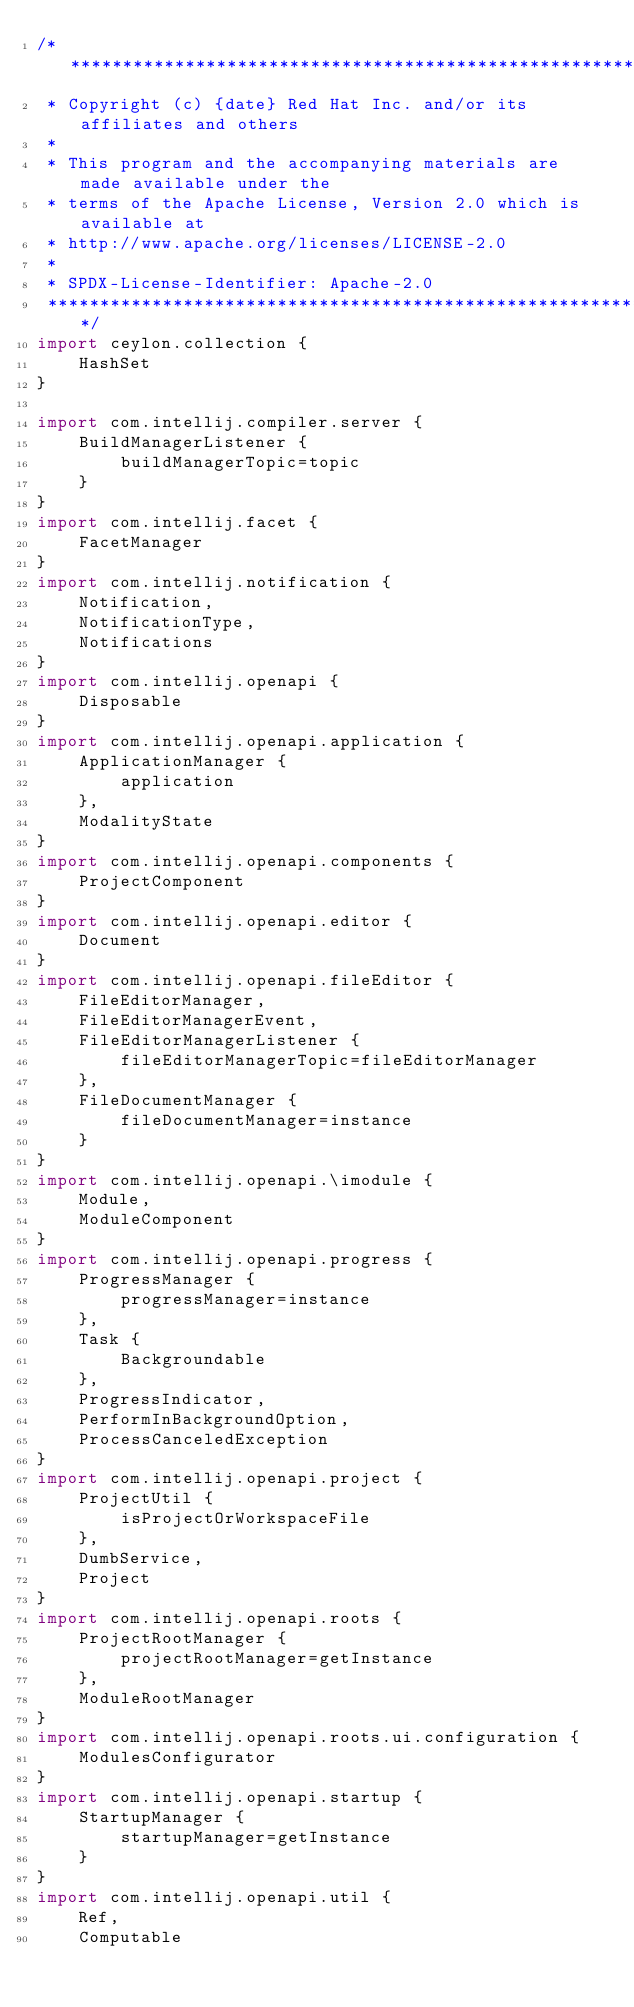<code> <loc_0><loc_0><loc_500><loc_500><_Ceylon_>/********************************************************************************
 * Copyright (c) {date} Red Hat Inc. and/or its affiliates and others
 *
 * This program and the accompanying materials are made available under the 
 * terms of the Apache License, Version 2.0 which is available at
 * http://www.apache.org/licenses/LICENSE-2.0
 *
 * SPDX-License-Identifier: Apache-2.0 
 ********************************************************************************/
import ceylon.collection {
    HashSet
}

import com.intellij.compiler.server {
    BuildManagerListener {
        buildManagerTopic=topic
    }
}
import com.intellij.facet {
    FacetManager
}
import com.intellij.notification {
    Notification,
    NotificationType,
    Notifications
}
import com.intellij.openapi {
    Disposable
}
import com.intellij.openapi.application {
    ApplicationManager {
        application
    },
    ModalityState
}
import com.intellij.openapi.components {
    ProjectComponent
}
import com.intellij.openapi.editor {
    Document
}
import com.intellij.openapi.fileEditor {
    FileEditorManager,
    FileEditorManagerEvent,
    FileEditorManagerListener {
        fileEditorManagerTopic=fileEditorManager
    },
    FileDocumentManager {
        fileDocumentManager=instance
    }
}
import com.intellij.openapi.\imodule {
    Module,
    ModuleComponent
}
import com.intellij.openapi.progress {
    ProgressManager {
        progressManager=instance
    },
    Task {
        Backgroundable
    },
    ProgressIndicator,
    PerformInBackgroundOption,
    ProcessCanceledException
}
import com.intellij.openapi.project {
    ProjectUtil {
        isProjectOrWorkspaceFile
    },
    DumbService,
    Project
}
import com.intellij.openapi.roots {
    ProjectRootManager {
        projectRootManager=getInstance
    },
    ModuleRootManager
}
import com.intellij.openapi.roots.ui.configuration {
    ModulesConfigurator
}
import com.intellij.openapi.startup {
    StartupManager {
        startupManager=getInstance
    }
}
import com.intellij.openapi.util {
    Ref,
    Computable</code> 